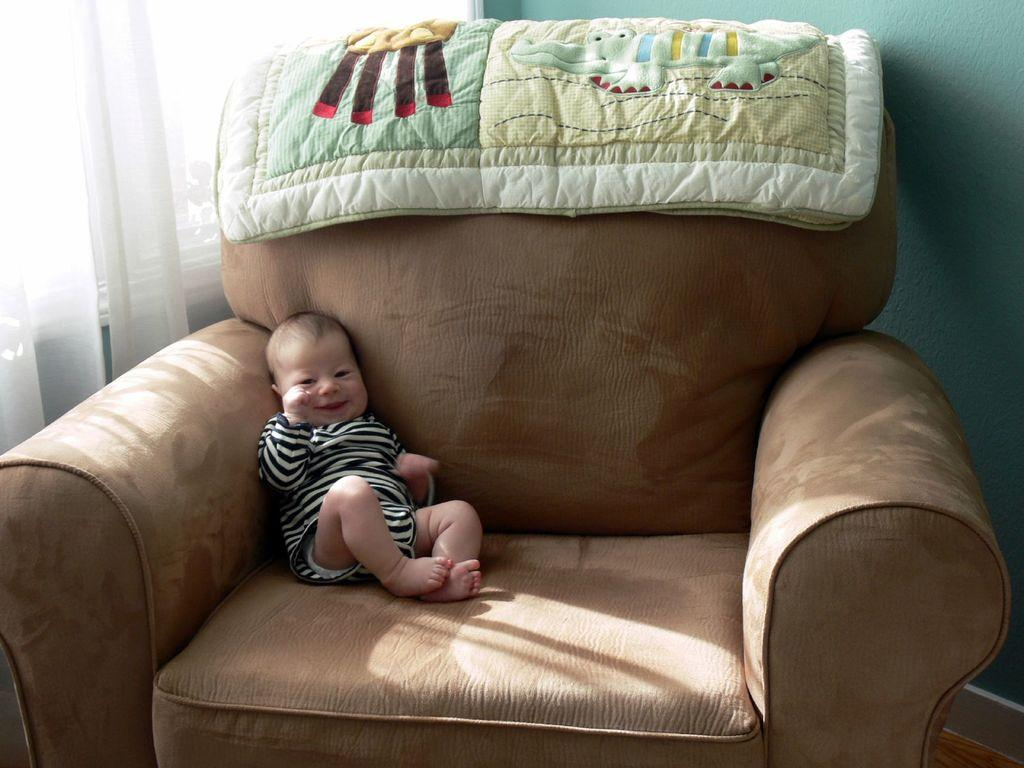What is the main subject of the image? There is a small baby in the image. Where is the baby located? The baby is on a sofa. What is covering the baby in the image? There is a baby blanket in the image. Can you describe the position of the blanket? The blanket is at the top side of the image. What can be seen in the background of the image? There is a curtain in the background of the image. What type of horn can be seen in the image? There is no horn present in the image. 